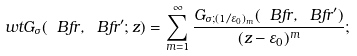<formula> <loc_0><loc_0><loc_500><loc_500>\ w t { G } _ { \sigma } ( { \ B f r } , { \ B f r } ^ { \prime } ; z ) = \sum _ { m = 1 } ^ { \infty } \frac { G _ { \sigma ; ( 1 / \varepsilon _ { 0 } ) _ { m } } ( { \ B f r } , { \ B f r } ^ { \prime } ) } { ( z - \varepsilon _ { 0 } ) ^ { m } } ;</formula> 